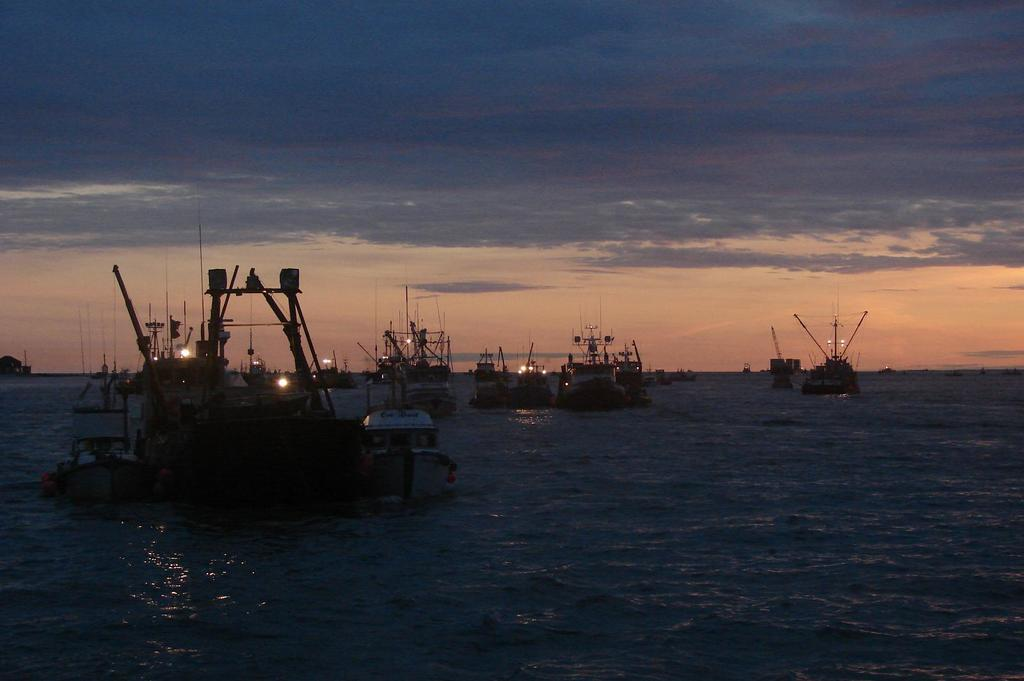What is the main feature of the image? The main feature of the image is a water surface. What is happening on the water surface? There are boats and ships sailing on the water. How many types of watercraft can be seen in the image? There are two types of watercraft: boats and ships. What type of body is visible in the image? There is no body visible in the image; it only features a water surface with boats and ships sailing on it. 